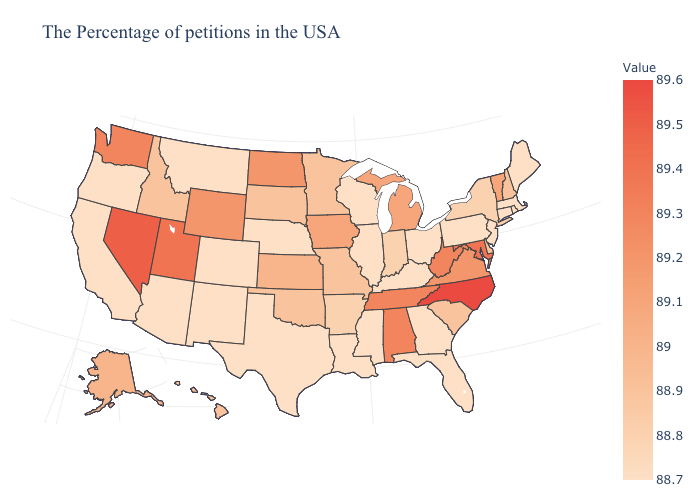Among the states that border Oregon , does Nevada have the highest value?
Give a very brief answer. Yes. Among the states that border Kansas , which have the highest value?
Concise answer only. Missouri, Oklahoma. Does Missouri have a lower value than Michigan?
Write a very short answer. Yes. Which states have the lowest value in the Northeast?
Give a very brief answer. Maine, Massachusetts, Rhode Island, Connecticut, New Jersey, Pennsylvania. Does Idaho have the highest value in the West?
Give a very brief answer. No. Which states have the lowest value in the Northeast?
Write a very short answer. Maine, Massachusetts, Rhode Island, Connecticut, New Jersey, Pennsylvania. 